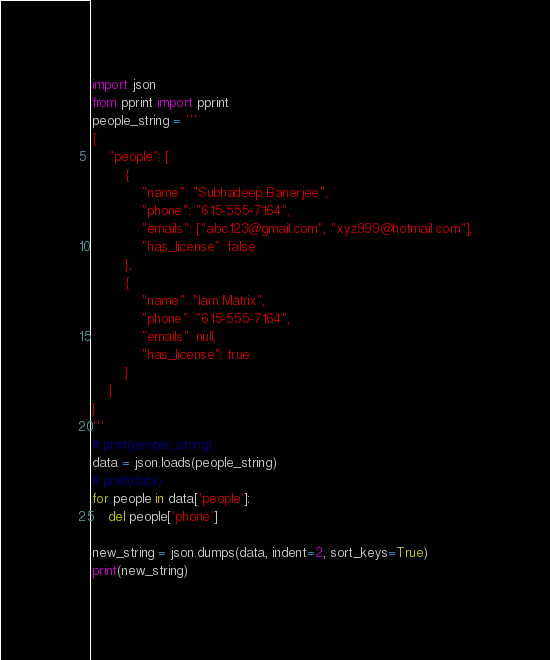Convert code to text. <code><loc_0><loc_0><loc_500><loc_500><_Python_>import json
from pprint import pprint
people_string = '''
{
    "people": [
        {
            "name": "Subhadeep Banerjee",
            "phone": "615-555-7164",
            "emails": ["abc123@gmail.com", "xyz999@hotmail.com"],
            "has_license": false
        },
        {
            "name": "Iam Matrix",
            "phone": "615-555-7164",
            "emails": null,
            "has_license": true
        }
    ]
}
'''
# print(people_string)
data = json.loads(people_string)
# print(data)
for people in data['people']:
    del people['phone']

new_string = json.dumps(data, indent=2, sort_keys=True)
print(new_string)
</code> 